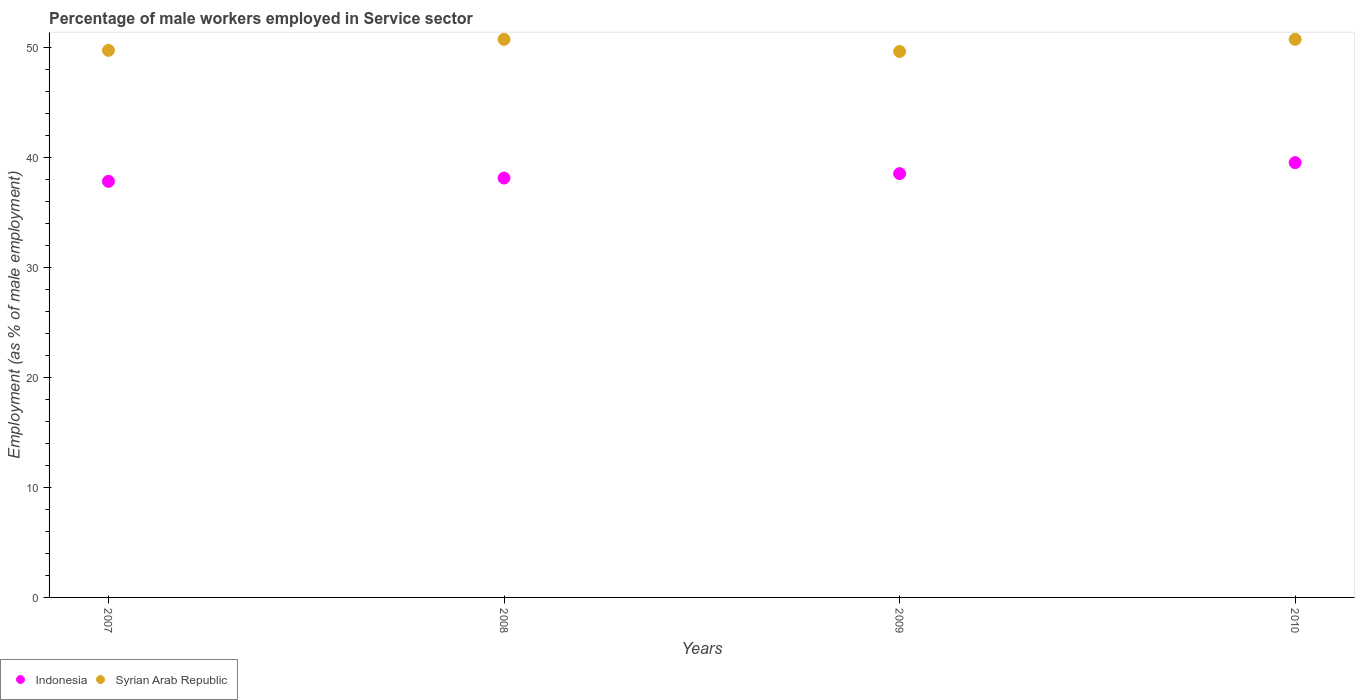How many different coloured dotlines are there?
Provide a short and direct response. 2. What is the percentage of male workers employed in Service sector in Syrian Arab Republic in 2008?
Offer a terse response. 50.7. Across all years, what is the maximum percentage of male workers employed in Service sector in Indonesia?
Give a very brief answer. 39.5. Across all years, what is the minimum percentage of male workers employed in Service sector in Syrian Arab Republic?
Your answer should be very brief. 49.6. In which year was the percentage of male workers employed in Service sector in Indonesia maximum?
Ensure brevity in your answer.  2010. What is the total percentage of male workers employed in Service sector in Indonesia in the graph?
Your answer should be very brief. 153.9. What is the difference between the percentage of male workers employed in Service sector in Syrian Arab Republic in 2009 and that in 2010?
Make the answer very short. -1.1. What is the difference between the percentage of male workers employed in Service sector in Indonesia in 2008 and the percentage of male workers employed in Service sector in Syrian Arab Republic in 2007?
Provide a short and direct response. -11.6. What is the average percentage of male workers employed in Service sector in Indonesia per year?
Your response must be concise. 38.47. In the year 2010, what is the difference between the percentage of male workers employed in Service sector in Syrian Arab Republic and percentage of male workers employed in Service sector in Indonesia?
Provide a succinct answer. 11.2. In how many years, is the percentage of male workers employed in Service sector in Syrian Arab Republic greater than 6 %?
Provide a short and direct response. 4. What is the ratio of the percentage of male workers employed in Service sector in Syrian Arab Republic in 2007 to that in 2010?
Ensure brevity in your answer.  0.98. Is the percentage of male workers employed in Service sector in Syrian Arab Republic in 2007 less than that in 2008?
Provide a short and direct response. Yes. What is the difference between the highest and the second highest percentage of male workers employed in Service sector in Syrian Arab Republic?
Your answer should be compact. 0. What is the difference between the highest and the lowest percentage of male workers employed in Service sector in Indonesia?
Ensure brevity in your answer.  1.7. In how many years, is the percentage of male workers employed in Service sector in Indonesia greater than the average percentage of male workers employed in Service sector in Indonesia taken over all years?
Your answer should be very brief. 2. Is the sum of the percentage of male workers employed in Service sector in Indonesia in 2007 and 2009 greater than the maximum percentage of male workers employed in Service sector in Syrian Arab Republic across all years?
Keep it short and to the point. Yes. Is the percentage of male workers employed in Service sector in Indonesia strictly greater than the percentage of male workers employed in Service sector in Syrian Arab Republic over the years?
Ensure brevity in your answer.  No. Is the percentage of male workers employed in Service sector in Indonesia strictly less than the percentage of male workers employed in Service sector in Syrian Arab Republic over the years?
Your response must be concise. Yes. How many dotlines are there?
Offer a terse response. 2. How many years are there in the graph?
Provide a succinct answer. 4. What is the difference between two consecutive major ticks on the Y-axis?
Offer a terse response. 10. Are the values on the major ticks of Y-axis written in scientific E-notation?
Offer a terse response. No. Does the graph contain grids?
Your response must be concise. No. How are the legend labels stacked?
Keep it short and to the point. Horizontal. What is the title of the graph?
Provide a short and direct response. Percentage of male workers employed in Service sector. Does "Burundi" appear as one of the legend labels in the graph?
Provide a succinct answer. No. What is the label or title of the X-axis?
Provide a succinct answer. Years. What is the label or title of the Y-axis?
Your response must be concise. Employment (as % of male employment). What is the Employment (as % of male employment) in Indonesia in 2007?
Offer a very short reply. 37.8. What is the Employment (as % of male employment) of Syrian Arab Republic in 2007?
Provide a short and direct response. 49.7. What is the Employment (as % of male employment) of Indonesia in 2008?
Your response must be concise. 38.1. What is the Employment (as % of male employment) in Syrian Arab Republic in 2008?
Provide a short and direct response. 50.7. What is the Employment (as % of male employment) of Indonesia in 2009?
Ensure brevity in your answer.  38.5. What is the Employment (as % of male employment) in Syrian Arab Republic in 2009?
Offer a very short reply. 49.6. What is the Employment (as % of male employment) of Indonesia in 2010?
Make the answer very short. 39.5. What is the Employment (as % of male employment) of Syrian Arab Republic in 2010?
Provide a short and direct response. 50.7. Across all years, what is the maximum Employment (as % of male employment) of Indonesia?
Provide a short and direct response. 39.5. Across all years, what is the maximum Employment (as % of male employment) in Syrian Arab Republic?
Provide a succinct answer. 50.7. Across all years, what is the minimum Employment (as % of male employment) in Indonesia?
Make the answer very short. 37.8. Across all years, what is the minimum Employment (as % of male employment) in Syrian Arab Republic?
Ensure brevity in your answer.  49.6. What is the total Employment (as % of male employment) of Indonesia in the graph?
Offer a very short reply. 153.9. What is the total Employment (as % of male employment) of Syrian Arab Republic in the graph?
Your answer should be compact. 200.7. What is the difference between the Employment (as % of male employment) of Indonesia in 2007 and that in 2008?
Ensure brevity in your answer.  -0.3. What is the difference between the Employment (as % of male employment) of Syrian Arab Republic in 2007 and that in 2008?
Your response must be concise. -1. What is the difference between the Employment (as % of male employment) of Indonesia in 2007 and that in 2009?
Ensure brevity in your answer.  -0.7. What is the difference between the Employment (as % of male employment) of Syrian Arab Republic in 2007 and that in 2009?
Give a very brief answer. 0.1. What is the difference between the Employment (as % of male employment) of Syrian Arab Republic in 2008 and that in 2009?
Provide a short and direct response. 1.1. What is the difference between the Employment (as % of male employment) in Indonesia in 2008 and that in 2010?
Offer a very short reply. -1.4. What is the difference between the Employment (as % of male employment) of Syrian Arab Republic in 2008 and that in 2010?
Your response must be concise. 0. What is the difference between the Employment (as % of male employment) in Indonesia in 2009 and that in 2010?
Provide a short and direct response. -1. What is the difference between the Employment (as % of male employment) in Syrian Arab Republic in 2009 and that in 2010?
Ensure brevity in your answer.  -1.1. What is the difference between the Employment (as % of male employment) of Indonesia in 2007 and the Employment (as % of male employment) of Syrian Arab Republic in 2008?
Your answer should be compact. -12.9. What is the difference between the Employment (as % of male employment) of Indonesia in 2008 and the Employment (as % of male employment) of Syrian Arab Republic in 2009?
Give a very brief answer. -11.5. What is the difference between the Employment (as % of male employment) in Indonesia in 2008 and the Employment (as % of male employment) in Syrian Arab Republic in 2010?
Offer a very short reply. -12.6. What is the difference between the Employment (as % of male employment) in Indonesia in 2009 and the Employment (as % of male employment) in Syrian Arab Republic in 2010?
Ensure brevity in your answer.  -12.2. What is the average Employment (as % of male employment) of Indonesia per year?
Offer a very short reply. 38.48. What is the average Employment (as % of male employment) of Syrian Arab Republic per year?
Provide a short and direct response. 50.17. In the year 2007, what is the difference between the Employment (as % of male employment) of Indonesia and Employment (as % of male employment) of Syrian Arab Republic?
Provide a short and direct response. -11.9. In the year 2008, what is the difference between the Employment (as % of male employment) of Indonesia and Employment (as % of male employment) of Syrian Arab Republic?
Give a very brief answer. -12.6. In the year 2009, what is the difference between the Employment (as % of male employment) in Indonesia and Employment (as % of male employment) in Syrian Arab Republic?
Ensure brevity in your answer.  -11.1. What is the ratio of the Employment (as % of male employment) in Syrian Arab Republic in 2007 to that in 2008?
Offer a very short reply. 0.98. What is the ratio of the Employment (as % of male employment) of Indonesia in 2007 to that in 2009?
Offer a terse response. 0.98. What is the ratio of the Employment (as % of male employment) of Syrian Arab Republic in 2007 to that in 2010?
Your response must be concise. 0.98. What is the ratio of the Employment (as % of male employment) in Indonesia in 2008 to that in 2009?
Make the answer very short. 0.99. What is the ratio of the Employment (as % of male employment) of Syrian Arab Republic in 2008 to that in 2009?
Offer a terse response. 1.02. What is the ratio of the Employment (as % of male employment) in Indonesia in 2008 to that in 2010?
Provide a succinct answer. 0.96. What is the ratio of the Employment (as % of male employment) of Indonesia in 2009 to that in 2010?
Provide a short and direct response. 0.97. What is the ratio of the Employment (as % of male employment) of Syrian Arab Republic in 2009 to that in 2010?
Your answer should be compact. 0.98. What is the difference between the highest and the lowest Employment (as % of male employment) of Syrian Arab Republic?
Make the answer very short. 1.1. 